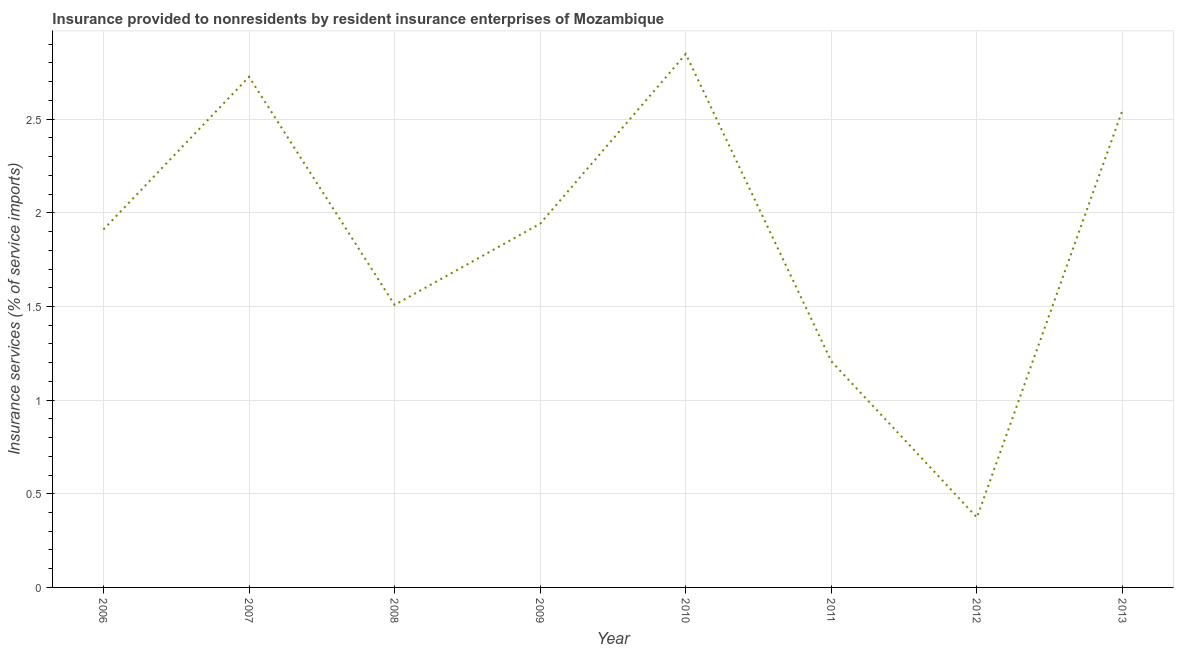What is the insurance and financial services in 2011?
Give a very brief answer. 1.21. Across all years, what is the maximum insurance and financial services?
Provide a succinct answer. 2.85. Across all years, what is the minimum insurance and financial services?
Offer a terse response. 0.37. In which year was the insurance and financial services maximum?
Give a very brief answer. 2010. What is the sum of the insurance and financial services?
Provide a short and direct response. 15.07. What is the difference between the insurance and financial services in 2006 and 2011?
Make the answer very short. 0.7. What is the average insurance and financial services per year?
Your answer should be very brief. 1.88. What is the median insurance and financial services?
Your response must be concise. 1.93. In how many years, is the insurance and financial services greater than 2.8 %?
Give a very brief answer. 1. What is the ratio of the insurance and financial services in 2009 to that in 2011?
Provide a short and direct response. 1.61. Is the insurance and financial services in 2006 less than that in 2009?
Your answer should be very brief. Yes. Is the difference between the insurance and financial services in 2009 and 2010 greater than the difference between any two years?
Keep it short and to the point. No. What is the difference between the highest and the second highest insurance and financial services?
Your answer should be compact. 0.12. What is the difference between the highest and the lowest insurance and financial services?
Keep it short and to the point. 2.47. In how many years, is the insurance and financial services greater than the average insurance and financial services taken over all years?
Your answer should be very brief. 5. Does the insurance and financial services monotonically increase over the years?
Your response must be concise. No. What is the difference between two consecutive major ticks on the Y-axis?
Offer a terse response. 0.5. Does the graph contain grids?
Provide a short and direct response. Yes. What is the title of the graph?
Provide a succinct answer. Insurance provided to nonresidents by resident insurance enterprises of Mozambique. What is the label or title of the X-axis?
Offer a very short reply. Year. What is the label or title of the Y-axis?
Make the answer very short. Insurance services (% of service imports). What is the Insurance services (% of service imports) of 2006?
Your answer should be compact. 1.91. What is the Insurance services (% of service imports) in 2007?
Your answer should be very brief. 2.73. What is the Insurance services (% of service imports) of 2008?
Your response must be concise. 1.51. What is the Insurance services (% of service imports) of 2009?
Offer a very short reply. 1.94. What is the Insurance services (% of service imports) in 2010?
Your response must be concise. 2.85. What is the Insurance services (% of service imports) of 2011?
Provide a short and direct response. 1.21. What is the Insurance services (% of service imports) in 2012?
Your response must be concise. 0.37. What is the Insurance services (% of service imports) in 2013?
Your response must be concise. 2.55. What is the difference between the Insurance services (% of service imports) in 2006 and 2007?
Your answer should be compact. -0.82. What is the difference between the Insurance services (% of service imports) in 2006 and 2008?
Your response must be concise. 0.4. What is the difference between the Insurance services (% of service imports) in 2006 and 2009?
Your answer should be compact. -0.03. What is the difference between the Insurance services (% of service imports) in 2006 and 2010?
Provide a succinct answer. -0.94. What is the difference between the Insurance services (% of service imports) in 2006 and 2011?
Offer a terse response. 0.7. What is the difference between the Insurance services (% of service imports) in 2006 and 2012?
Your answer should be very brief. 1.54. What is the difference between the Insurance services (% of service imports) in 2006 and 2013?
Your answer should be very brief. -0.64. What is the difference between the Insurance services (% of service imports) in 2007 and 2008?
Your answer should be compact. 1.22. What is the difference between the Insurance services (% of service imports) in 2007 and 2009?
Ensure brevity in your answer.  0.78. What is the difference between the Insurance services (% of service imports) in 2007 and 2010?
Your answer should be very brief. -0.12. What is the difference between the Insurance services (% of service imports) in 2007 and 2011?
Offer a very short reply. 1.52. What is the difference between the Insurance services (% of service imports) in 2007 and 2012?
Offer a very short reply. 2.35. What is the difference between the Insurance services (% of service imports) in 2007 and 2013?
Give a very brief answer. 0.18. What is the difference between the Insurance services (% of service imports) in 2008 and 2009?
Make the answer very short. -0.43. What is the difference between the Insurance services (% of service imports) in 2008 and 2010?
Your response must be concise. -1.34. What is the difference between the Insurance services (% of service imports) in 2008 and 2011?
Ensure brevity in your answer.  0.3. What is the difference between the Insurance services (% of service imports) in 2008 and 2012?
Ensure brevity in your answer.  1.14. What is the difference between the Insurance services (% of service imports) in 2008 and 2013?
Your response must be concise. -1.04. What is the difference between the Insurance services (% of service imports) in 2009 and 2010?
Give a very brief answer. -0.91. What is the difference between the Insurance services (% of service imports) in 2009 and 2011?
Ensure brevity in your answer.  0.74. What is the difference between the Insurance services (% of service imports) in 2009 and 2012?
Make the answer very short. 1.57. What is the difference between the Insurance services (% of service imports) in 2009 and 2013?
Ensure brevity in your answer.  -0.61. What is the difference between the Insurance services (% of service imports) in 2010 and 2011?
Make the answer very short. 1.64. What is the difference between the Insurance services (% of service imports) in 2010 and 2012?
Your answer should be compact. 2.47. What is the difference between the Insurance services (% of service imports) in 2010 and 2013?
Offer a terse response. 0.3. What is the difference between the Insurance services (% of service imports) in 2011 and 2012?
Keep it short and to the point. 0.83. What is the difference between the Insurance services (% of service imports) in 2011 and 2013?
Your response must be concise. -1.34. What is the difference between the Insurance services (% of service imports) in 2012 and 2013?
Ensure brevity in your answer.  -2.18. What is the ratio of the Insurance services (% of service imports) in 2006 to that in 2007?
Offer a terse response. 0.7. What is the ratio of the Insurance services (% of service imports) in 2006 to that in 2008?
Offer a terse response. 1.27. What is the ratio of the Insurance services (% of service imports) in 2006 to that in 2009?
Your response must be concise. 0.98. What is the ratio of the Insurance services (% of service imports) in 2006 to that in 2010?
Offer a terse response. 0.67. What is the ratio of the Insurance services (% of service imports) in 2006 to that in 2011?
Make the answer very short. 1.58. What is the ratio of the Insurance services (% of service imports) in 2006 to that in 2012?
Your response must be concise. 5.12. What is the ratio of the Insurance services (% of service imports) in 2006 to that in 2013?
Make the answer very short. 0.75. What is the ratio of the Insurance services (% of service imports) in 2007 to that in 2008?
Provide a short and direct response. 1.81. What is the ratio of the Insurance services (% of service imports) in 2007 to that in 2009?
Make the answer very short. 1.4. What is the ratio of the Insurance services (% of service imports) in 2007 to that in 2010?
Provide a succinct answer. 0.96. What is the ratio of the Insurance services (% of service imports) in 2007 to that in 2011?
Make the answer very short. 2.26. What is the ratio of the Insurance services (% of service imports) in 2007 to that in 2012?
Give a very brief answer. 7.3. What is the ratio of the Insurance services (% of service imports) in 2007 to that in 2013?
Offer a terse response. 1.07. What is the ratio of the Insurance services (% of service imports) in 2008 to that in 2009?
Ensure brevity in your answer.  0.78. What is the ratio of the Insurance services (% of service imports) in 2008 to that in 2010?
Ensure brevity in your answer.  0.53. What is the ratio of the Insurance services (% of service imports) in 2008 to that in 2011?
Give a very brief answer. 1.25. What is the ratio of the Insurance services (% of service imports) in 2008 to that in 2012?
Give a very brief answer. 4.04. What is the ratio of the Insurance services (% of service imports) in 2008 to that in 2013?
Provide a short and direct response. 0.59. What is the ratio of the Insurance services (% of service imports) in 2009 to that in 2010?
Provide a succinct answer. 0.68. What is the ratio of the Insurance services (% of service imports) in 2009 to that in 2011?
Make the answer very short. 1.61. What is the ratio of the Insurance services (% of service imports) in 2009 to that in 2012?
Your answer should be very brief. 5.2. What is the ratio of the Insurance services (% of service imports) in 2009 to that in 2013?
Offer a very short reply. 0.76. What is the ratio of the Insurance services (% of service imports) in 2010 to that in 2011?
Keep it short and to the point. 2.36. What is the ratio of the Insurance services (% of service imports) in 2010 to that in 2012?
Give a very brief answer. 7.63. What is the ratio of the Insurance services (% of service imports) in 2010 to that in 2013?
Provide a succinct answer. 1.12. What is the ratio of the Insurance services (% of service imports) in 2011 to that in 2012?
Your answer should be very brief. 3.23. What is the ratio of the Insurance services (% of service imports) in 2011 to that in 2013?
Keep it short and to the point. 0.47. What is the ratio of the Insurance services (% of service imports) in 2012 to that in 2013?
Your answer should be very brief. 0.15. 